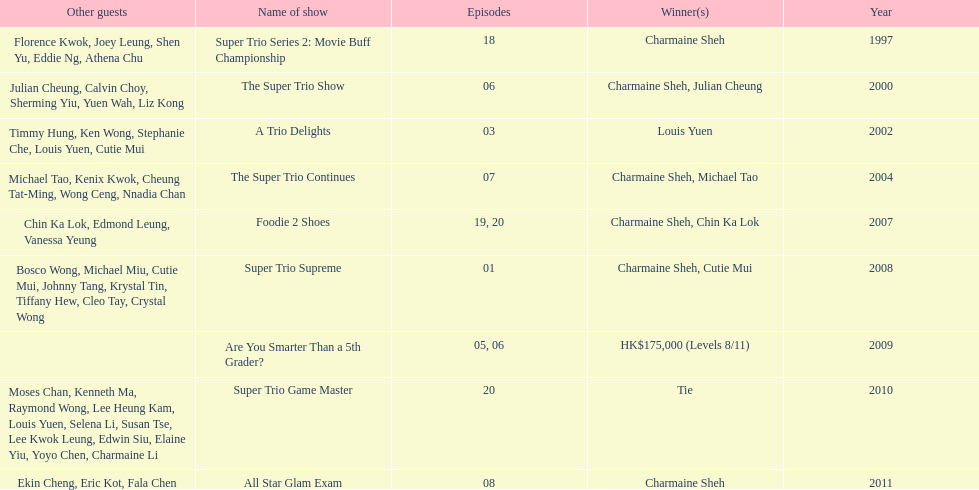What is the number of tv shows that charmaine sheh has appeared on? 9. 